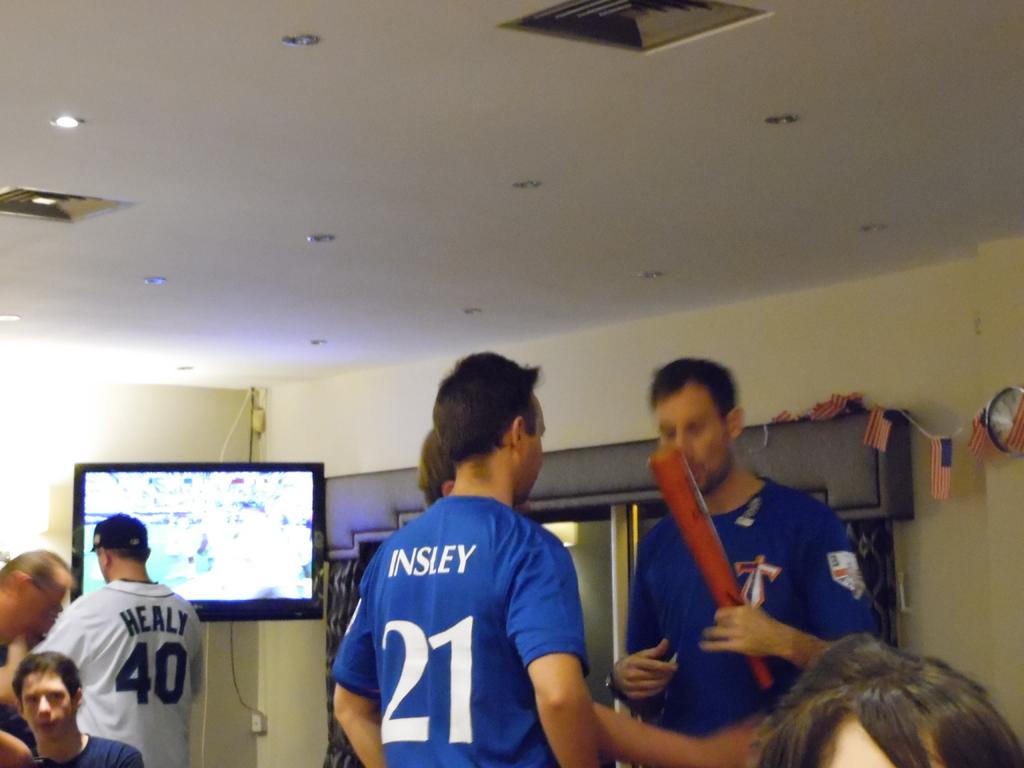What jersey number is on the blue one?
Give a very brief answer. 21. What is the last name of player 40?
Your answer should be very brief. Healy. 